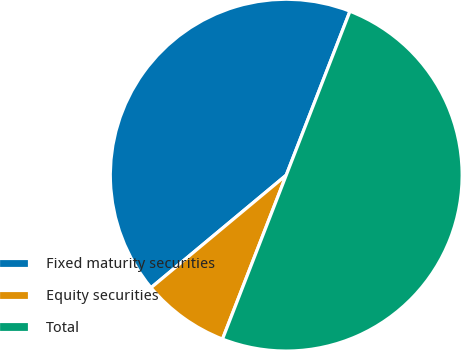Convert chart to OTSL. <chart><loc_0><loc_0><loc_500><loc_500><pie_chart><fcel>Fixed maturity securities<fcel>Equity securities<fcel>Total<nl><fcel>41.95%<fcel>8.05%<fcel>50.0%<nl></chart> 